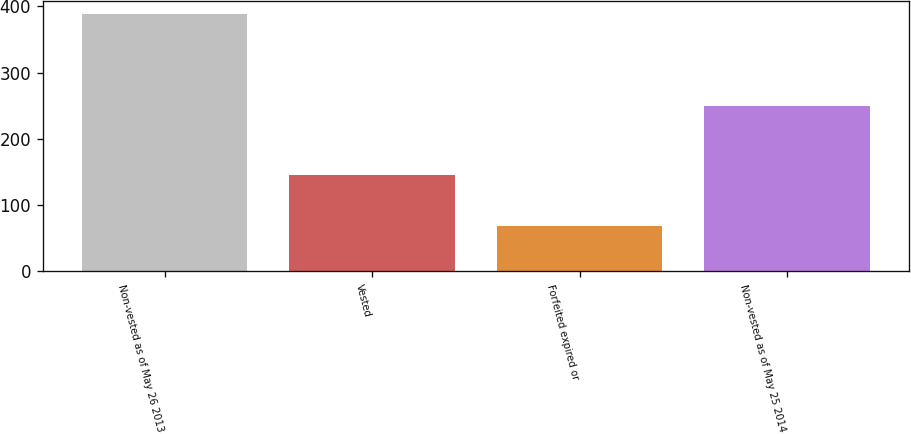Convert chart to OTSL. <chart><loc_0><loc_0><loc_500><loc_500><bar_chart><fcel>Non-vested as of May 26 2013<fcel>Vested<fcel>Forfeited expired or<fcel>Non-vested as of May 25 2014<nl><fcel>388.2<fcel>144.9<fcel>68.1<fcel>249.5<nl></chart> 